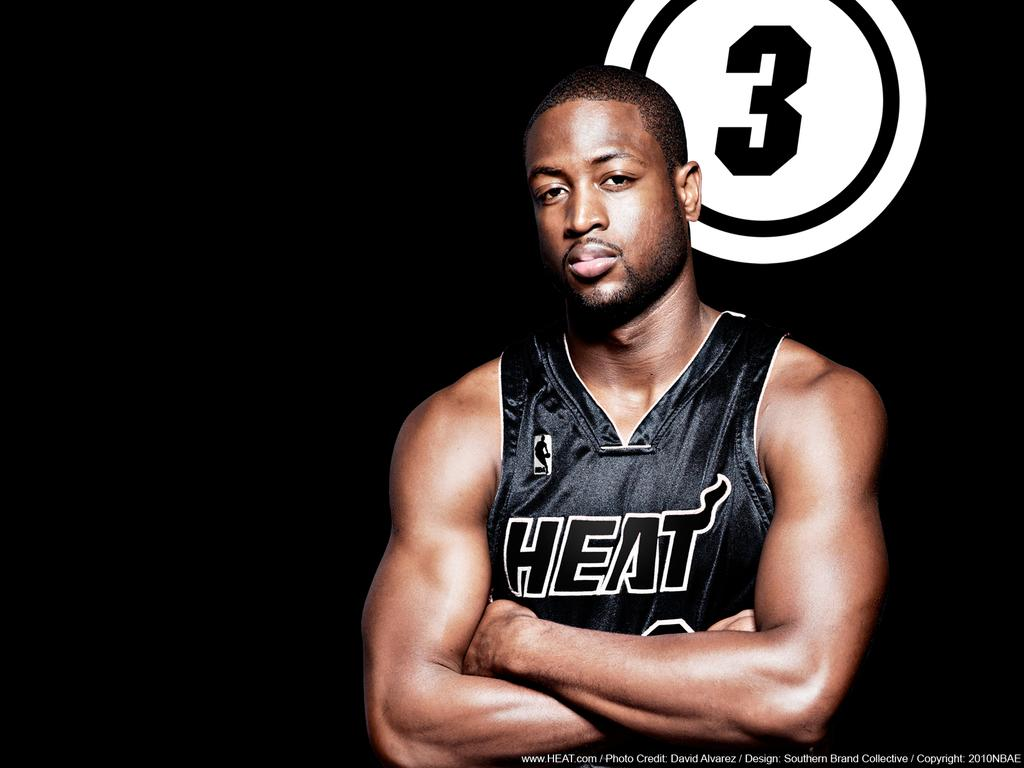<image>
Provide a brief description of the given image. A player for the Heat is looking at the camera with his arms crossed. 